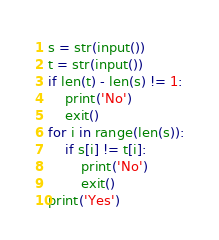<code> <loc_0><loc_0><loc_500><loc_500><_Python_>s = str(input())
t = str(input())
if len(t) - len(s) != 1:
    print('No')
    exit()
for i in range(len(s)):
    if s[i] != t[i]:
        print('No')
        exit()
print('Yes')</code> 